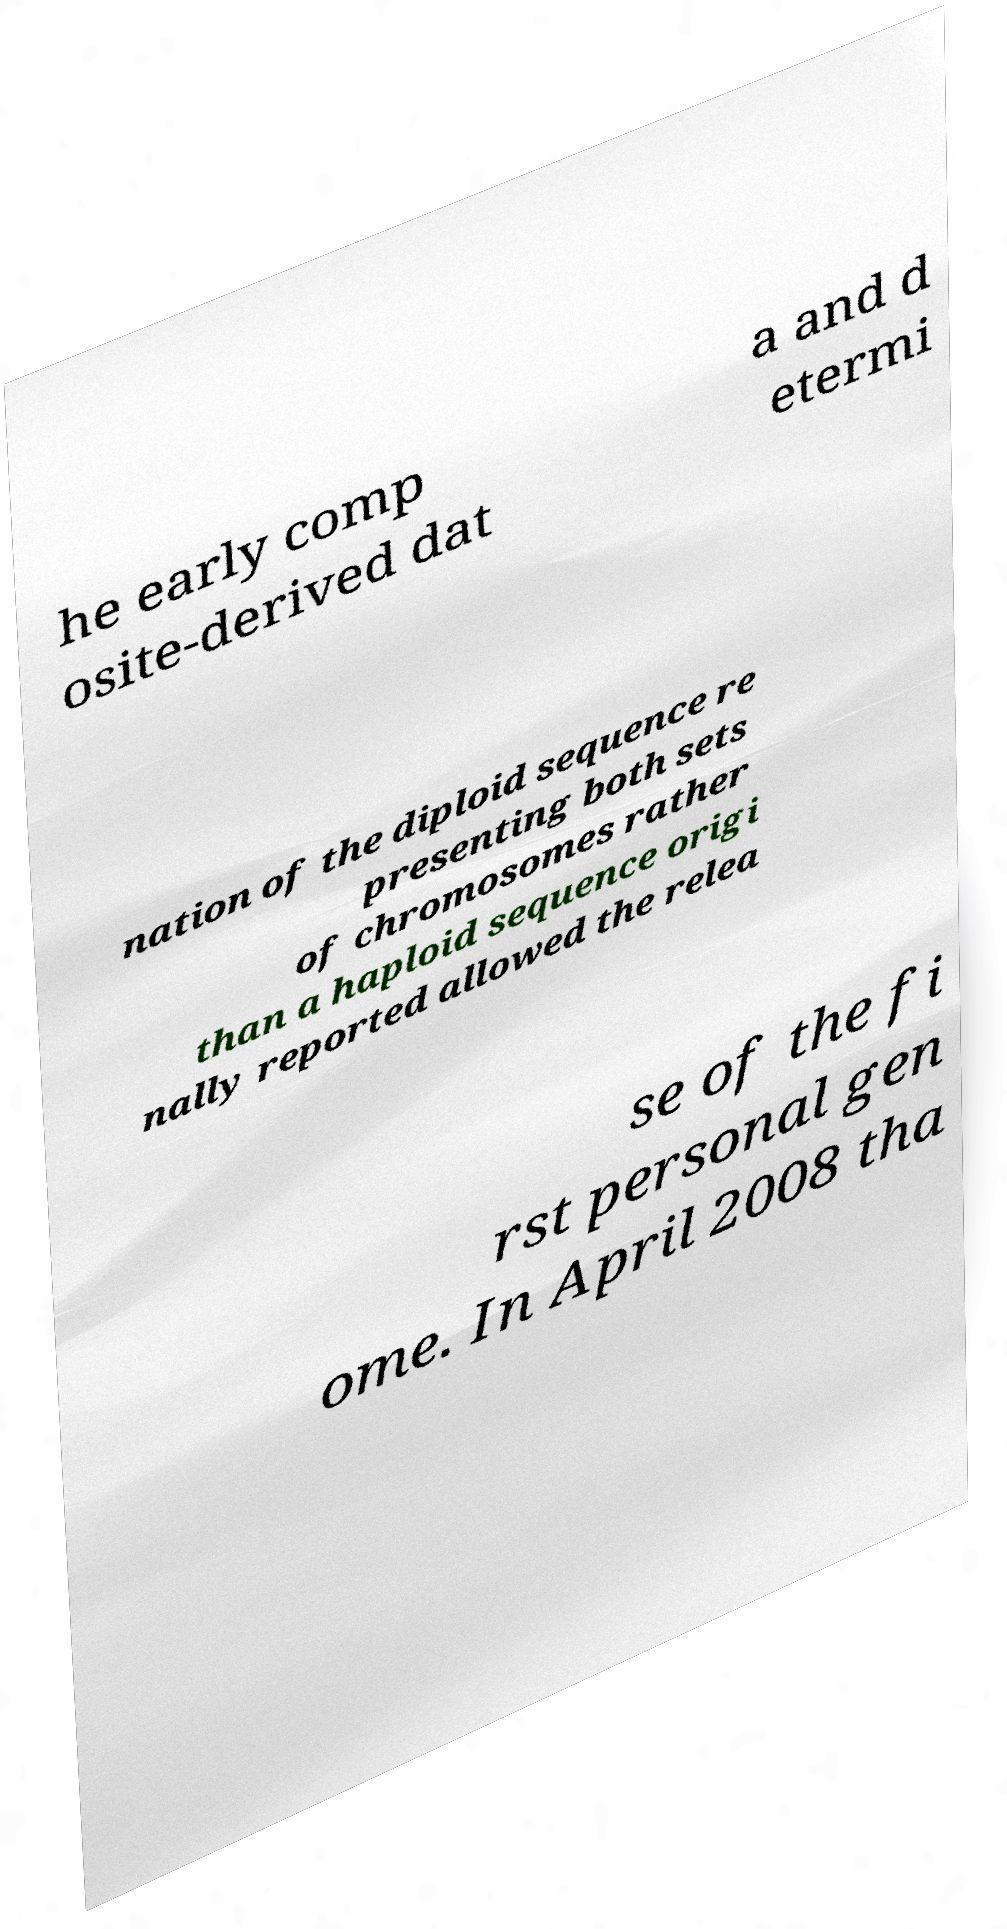Can you accurately transcribe the text from the provided image for me? he early comp osite-derived dat a and d etermi nation of the diploid sequence re presenting both sets of chromosomes rather than a haploid sequence origi nally reported allowed the relea se of the fi rst personal gen ome. In April 2008 tha 